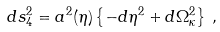<formula> <loc_0><loc_0><loc_500><loc_500>d s _ { 4 } ^ { 2 } = a ^ { 2 } ( \eta ) \left \{ - d \eta ^ { 2 } + d \Omega _ { \kappa } ^ { 2 } \right \} \, ,</formula> 